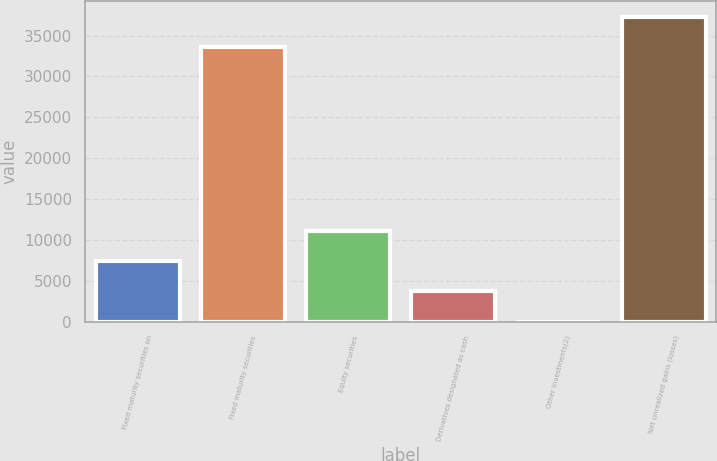Convert chart to OTSL. <chart><loc_0><loc_0><loc_500><loc_500><bar_chart><fcel>Fixed maturity securities on<fcel>Fixed maturity securities<fcel>Equity securities<fcel>Derivatives designated as cash<fcel>Other investments(2)<fcel>Net unrealized gains (losses)<nl><fcel>7428.2<fcel>33625<fcel>11138.8<fcel>3717.6<fcel>7<fcel>37335.6<nl></chart> 